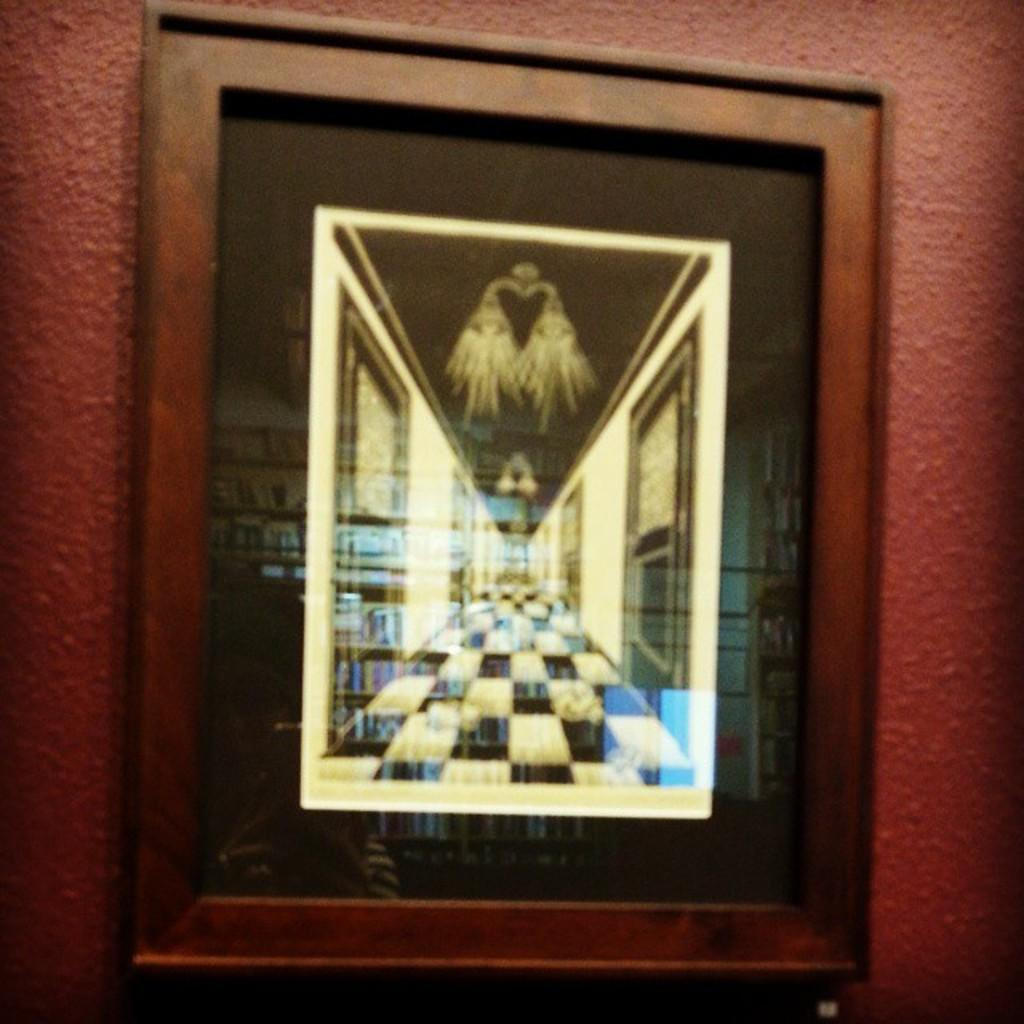What object can be seen in the image that is typically used for displaying photos? There is a photo frame in the image. Where is the photo frame located in the image? The photo frame is on the wall. What type of fang can be seen hanging from the photo frame in the image? There is no fang present in the image; it only features a photo frame on the wall. 